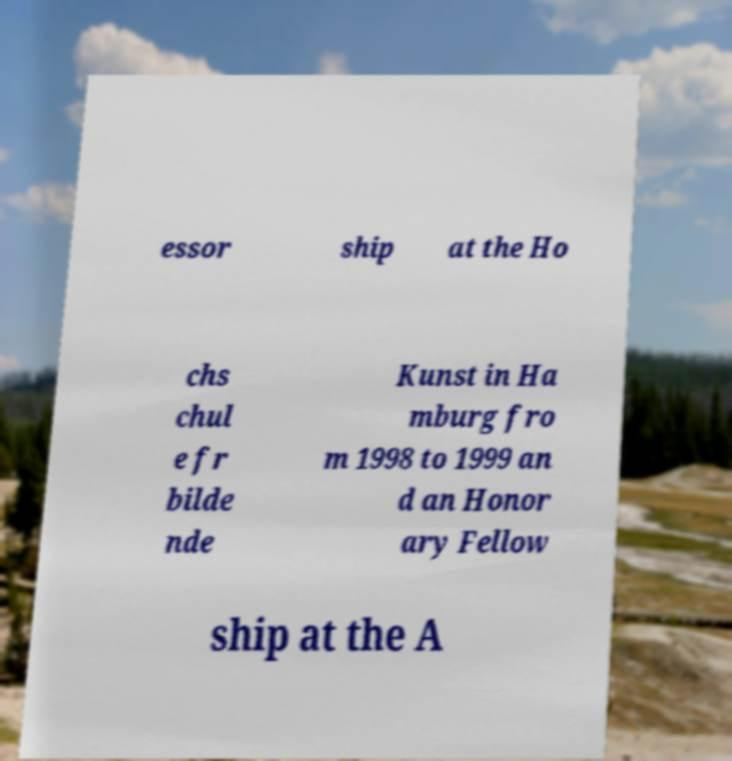Please read and relay the text visible in this image. What does it say? essor ship at the Ho chs chul e fr bilde nde Kunst in Ha mburg fro m 1998 to 1999 an d an Honor ary Fellow ship at the A 